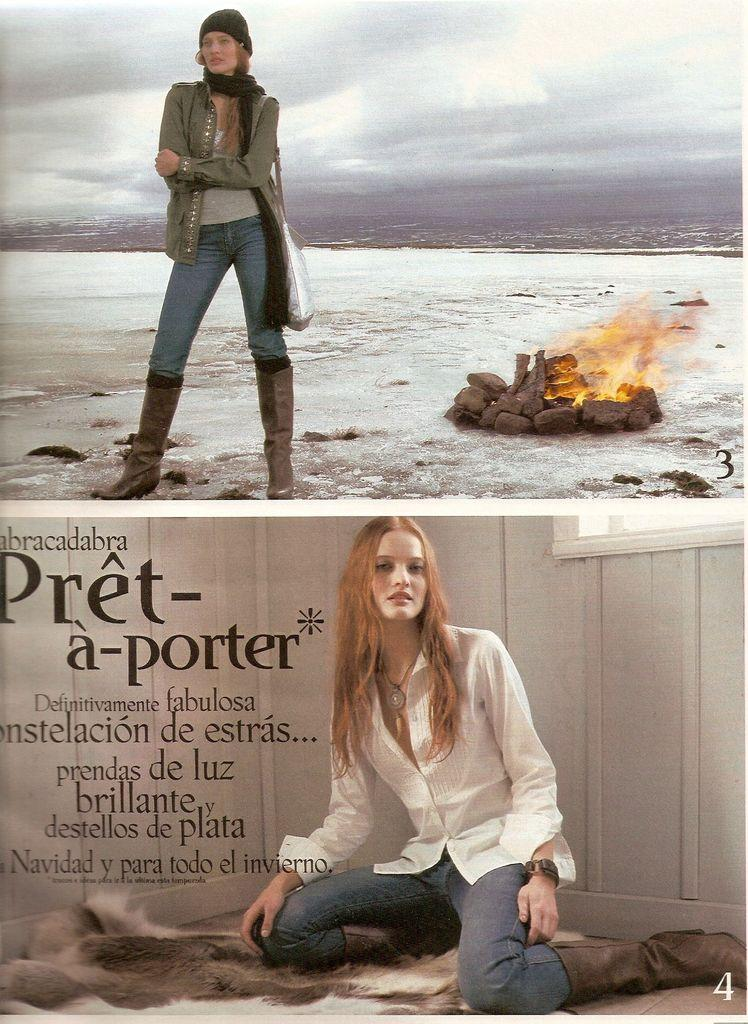How many women are present in the image? There are two women in the image, one sitting and one standing. What is the setting of the image? The image features stones and fire, suggesting an outdoor or campfire setting. What can be seen in the sky in the image? The sky is visible in the image. What might the women be doing in the image? It is unclear what the women are doing, but their presence near the fire and stones could suggest they are participating in an activity or gathering. What type of cherries are being served at the feast in the image? There is no feast or cherries present in the image; it features two women, stones, fire, and a visible sky. 